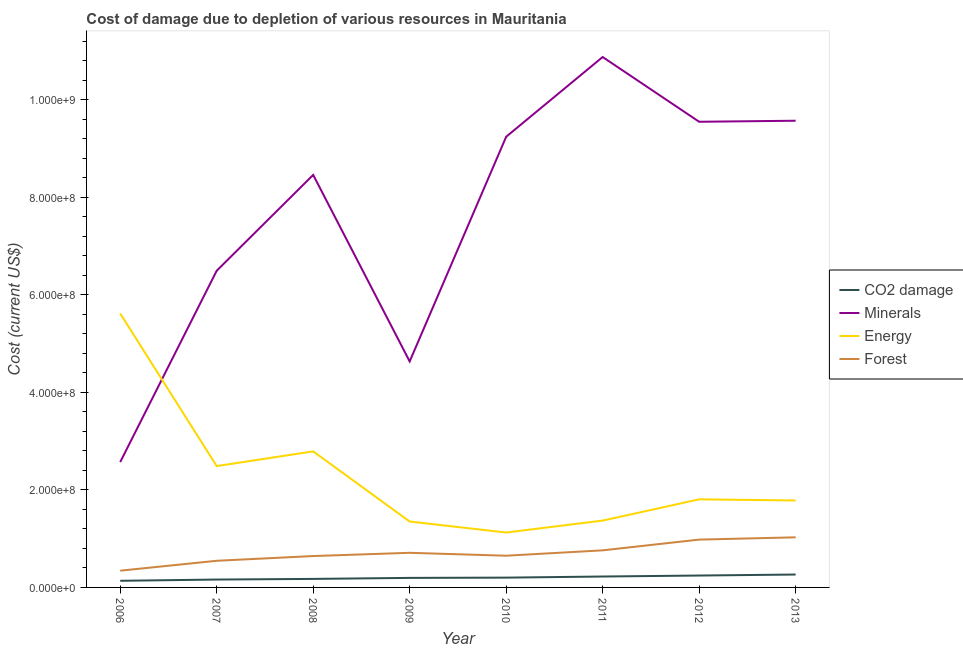Is the number of lines equal to the number of legend labels?
Your answer should be very brief. Yes. What is the cost of damage due to depletion of forests in 2012?
Offer a very short reply. 9.81e+07. Across all years, what is the maximum cost of damage due to depletion of minerals?
Your answer should be very brief. 1.09e+09. Across all years, what is the minimum cost of damage due to depletion of forests?
Offer a terse response. 3.44e+07. In which year was the cost of damage due to depletion of minerals minimum?
Provide a succinct answer. 2006. What is the total cost of damage due to depletion of forests in the graph?
Give a very brief answer. 5.66e+08. What is the difference between the cost of damage due to depletion of forests in 2009 and that in 2012?
Keep it short and to the point. -2.71e+07. What is the difference between the cost of damage due to depletion of minerals in 2011 and the cost of damage due to depletion of coal in 2007?
Provide a succinct answer. 1.07e+09. What is the average cost of damage due to depletion of minerals per year?
Offer a terse response. 7.68e+08. In the year 2011, what is the difference between the cost of damage due to depletion of minerals and cost of damage due to depletion of coal?
Provide a succinct answer. 1.07e+09. In how many years, is the cost of damage due to depletion of forests greater than 240000000 US$?
Provide a short and direct response. 0. What is the ratio of the cost of damage due to depletion of minerals in 2007 to that in 2013?
Your response must be concise. 0.68. What is the difference between the highest and the second highest cost of damage due to depletion of coal?
Offer a very short reply. 2.04e+06. What is the difference between the highest and the lowest cost of damage due to depletion of forests?
Your response must be concise. 6.84e+07. In how many years, is the cost of damage due to depletion of minerals greater than the average cost of damage due to depletion of minerals taken over all years?
Your answer should be compact. 5. Is the cost of damage due to depletion of forests strictly greater than the cost of damage due to depletion of minerals over the years?
Keep it short and to the point. No. Is the cost of damage due to depletion of energy strictly less than the cost of damage due to depletion of coal over the years?
Provide a succinct answer. No. How many lines are there?
Your response must be concise. 4. How many years are there in the graph?
Keep it short and to the point. 8. What is the difference between two consecutive major ticks on the Y-axis?
Offer a very short reply. 2.00e+08. Are the values on the major ticks of Y-axis written in scientific E-notation?
Keep it short and to the point. Yes. How are the legend labels stacked?
Your answer should be compact. Vertical. What is the title of the graph?
Offer a terse response. Cost of damage due to depletion of various resources in Mauritania . What is the label or title of the X-axis?
Provide a short and direct response. Year. What is the label or title of the Y-axis?
Keep it short and to the point. Cost (current US$). What is the Cost (current US$) in CO2 damage in 2006?
Your response must be concise. 1.36e+07. What is the Cost (current US$) in Minerals in 2006?
Offer a terse response. 2.57e+08. What is the Cost (current US$) of Energy in 2006?
Your response must be concise. 5.62e+08. What is the Cost (current US$) in Forest in 2006?
Your response must be concise. 3.44e+07. What is the Cost (current US$) in CO2 damage in 2007?
Make the answer very short. 1.62e+07. What is the Cost (current US$) of Minerals in 2007?
Provide a short and direct response. 6.50e+08. What is the Cost (current US$) of Energy in 2007?
Offer a very short reply. 2.49e+08. What is the Cost (current US$) in Forest in 2007?
Give a very brief answer. 5.47e+07. What is the Cost (current US$) of CO2 damage in 2008?
Your answer should be very brief. 1.75e+07. What is the Cost (current US$) of Minerals in 2008?
Your answer should be compact. 8.46e+08. What is the Cost (current US$) in Energy in 2008?
Provide a short and direct response. 2.79e+08. What is the Cost (current US$) in Forest in 2008?
Your answer should be very brief. 6.44e+07. What is the Cost (current US$) in CO2 damage in 2009?
Offer a very short reply. 1.96e+07. What is the Cost (current US$) of Minerals in 2009?
Provide a succinct answer. 4.64e+08. What is the Cost (current US$) of Energy in 2009?
Your answer should be compact. 1.35e+08. What is the Cost (current US$) in Forest in 2009?
Give a very brief answer. 7.10e+07. What is the Cost (current US$) in CO2 damage in 2010?
Your response must be concise. 2.01e+07. What is the Cost (current US$) in Minerals in 2010?
Your response must be concise. 9.25e+08. What is the Cost (current US$) in Energy in 2010?
Offer a very short reply. 1.13e+08. What is the Cost (current US$) in Forest in 2010?
Make the answer very short. 6.51e+07. What is the Cost (current US$) of CO2 damage in 2011?
Keep it short and to the point. 2.24e+07. What is the Cost (current US$) in Minerals in 2011?
Offer a very short reply. 1.09e+09. What is the Cost (current US$) in Energy in 2011?
Ensure brevity in your answer.  1.37e+08. What is the Cost (current US$) in Forest in 2011?
Your answer should be very brief. 7.61e+07. What is the Cost (current US$) of CO2 damage in 2012?
Your answer should be very brief. 2.44e+07. What is the Cost (current US$) of Minerals in 2012?
Provide a succinct answer. 9.55e+08. What is the Cost (current US$) of Energy in 2012?
Provide a succinct answer. 1.81e+08. What is the Cost (current US$) of Forest in 2012?
Keep it short and to the point. 9.81e+07. What is the Cost (current US$) in CO2 damage in 2013?
Give a very brief answer. 2.65e+07. What is the Cost (current US$) in Minerals in 2013?
Ensure brevity in your answer.  9.57e+08. What is the Cost (current US$) of Energy in 2013?
Offer a very short reply. 1.78e+08. What is the Cost (current US$) in Forest in 2013?
Offer a terse response. 1.03e+08. Across all years, what is the maximum Cost (current US$) in CO2 damage?
Your answer should be very brief. 2.65e+07. Across all years, what is the maximum Cost (current US$) in Minerals?
Provide a short and direct response. 1.09e+09. Across all years, what is the maximum Cost (current US$) of Energy?
Ensure brevity in your answer.  5.62e+08. Across all years, what is the maximum Cost (current US$) of Forest?
Give a very brief answer. 1.03e+08. Across all years, what is the minimum Cost (current US$) in CO2 damage?
Ensure brevity in your answer.  1.36e+07. Across all years, what is the minimum Cost (current US$) in Minerals?
Your answer should be very brief. 2.57e+08. Across all years, what is the minimum Cost (current US$) of Energy?
Make the answer very short. 1.13e+08. Across all years, what is the minimum Cost (current US$) of Forest?
Your response must be concise. 3.44e+07. What is the total Cost (current US$) in CO2 damage in the graph?
Ensure brevity in your answer.  1.60e+08. What is the total Cost (current US$) in Minerals in the graph?
Offer a very short reply. 6.14e+09. What is the total Cost (current US$) of Energy in the graph?
Provide a succinct answer. 1.83e+09. What is the total Cost (current US$) in Forest in the graph?
Keep it short and to the point. 5.66e+08. What is the difference between the Cost (current US$) of CO2 damage in 2006 and that in 2007?
Your response must be concise. -2.56e+06. What is the difference between the Cost (current US$) in Minerals in 2006 and that in 2007?
Offer a terse response. -3.93e+08. What is the difference between the Cost (current US$) of Energy in 2006 and that in 2007?
Provide a short and direct response. 3.13e+08. What is the difference between the Cost (current US$) in Forest in 2006 and that in 2007?
Your answer should be compact. -2.03e+07. What is the difference between the Cost (current US$) of CO2 damage in 2006 and that in 2008?
Your answer should be compact. -3.88e+06. What is the difference between the Cost (current US$) in Minerals in 2006 and that in 2008?
Offer a terse response. -5.89e+08. What is the difference between the Cost (current US$) in Energy in 2006 and that in 2008?
Your answer should be very brief. 2.83e+08. What is the difference between the Cost (current US$) of Forest in 2006 and that in 2008?
Make the answer very short. -3.00e+07. What is the difference between the Cost (current US$) in CO2 damage in 2006 and that in 2009?
Provide a succinct answer. -5.98e+06. What is the difference between the Cost (current US$) in Minerals in 2006 and that in 2009?
Provide a succinct answer. -2.07e+08. What is the difference between the Cost (current US$) in Energy in 2006 and that in 2009?
Provide a short and direct response. 4.27e+08. What is the difference between the Cost (current US$) in Forest in 2006 and that in 2009?
Offer a terse response. -3.67e+07. What is the difference between the Cost (current US$) in CO2 damage in 2006 and that in 2010?
Keep it short and to the point. -6.50e+06. What is the difference between the Cost (current US$) of Minerals in 2006 and that in 2010?
Make the answer very short. -6.67e+08. What is the difference between the Cost (current US$) of Energy in 2006 and that in 2010?
Give a very brief answer. 4.49e+08. What is the difference between the Cost (current US$) of Forest in 2006 and that in 2010?
Make the answer very short. -3.07e+07. What is the difference between the Cost (current US$) of CO2 damage in 2006 and that in 2011?
Offer a terse response. -8.80e+06. What is the difference between the Cost (current US$) of Minerals in 2006 and that in 2011?
Provide a short and direct response. -8.31e+08. What is the difference between the Cost (current US$) in Energy in 2006 and that in 2011?
Ensure brevity in your answer.  4.25e+08. What is the difference between the Cost (current US$) of Forest in 2006 and that in 2011?
Provide a short and direct response. -4.17e+07. What is the difference between the Cost (current US$) of CO2 damage in 2006 and that in 2012?
Provide a succinct answer. -1.08e+07. What is the difference between the Cost (current US$) of Minerals in 2006 and that in 2012?
Offer a terse response. -6.98e+08. What is the difference between the Cost (current US$) of Energy in 2006 and that in 2012?
Provide a succinct answer. 3.81e+08. What is the difference between the Cost (current US$) in Forest in 2006 and that in 2012?
Make the answer very short. -6.38e+07. What is the difference between the Cost (current US$) in CO2 damage in 2006 and that in 2013?
Keep it short and to the point. -1.29e+07. What is the difference between the Cost (current US$) in Minerals in 2006 and that in 2013?
Your response must be concise. -7.00e+08. What is the difference between the Cost (current US$) in Energy in 2006 and that in 2013?
Offer a very short reply. 3.84e+08. What is the difference between the Cost (current US$) of Forest in 2006 and that in 2013?
Your answer should be very brief. -6.84e+07. What is the difference between the Cost (current US$) of CO2 damage in 2007 and that in 2008?
Provide a short and direct response. -1.32e+06. What is the difference between the Cost (current US$) in Minerals in 2007 and that in 2008?
Provide a short and direct response. -1.97e+08. What is the difference between the Cost (current US$) of Energy in 2007 and that in 2008?
Give a very brief answer. -3.02e+07. What is the difference between the Cost (current US$) of Forest in 2007 and that in 2008?
Give a very brief answer. -9.72e+06. What is the difference between the Cost (current US$) of CO2 damage in 2007 and that in 2009?
Offer a very short reply. -3.42e+06. What is the difference between the Cost (current US$) in Minerals in 2007 and that in 2009?
Give a very brief answer. 1.86e+08. What is the difference between the Cost (current US$) in Energy in 2007 and that in 2009?
Offer a terse response. 1.14e+08. What is the difference between the Cost (current US$) in Forest in 2007 and that in 2009?
Make the answer very short. -1.64e+07. What is the difference between the Cost (current US$) in CO2 damage in 2007 and that in 2010?
Offer a very short reply. -3.94e+06. What is the difference between the Cost (current US$) of Minerals in 2007 and that in 2010?
Offer a very short reply. -2.75e+08. What is the difference between the Cost (current US$) in Energy in 2007 and that in 2010?
Keep it short and to the point. 1.36e+08. What is the difference between the Cost (current US$) in Forest in 2007 and that in 2010?
Your answer should be very brief. -1.04e+07. What is the difference between the Cost (current US$) of CO2 damage in 2007 and that in 2011?
Make the answer very short. -6.24e+06. What is the difference between the Cost (current US$) in Minerals in 2007 and that in 2011?
Offer a terse response. -4.38e+08. What is the difference between the Cost (current US$) of Energy in 2007 and that in 2011?
Provide a short and direct response. 1.12e+08. What is the difference between the Cost (current US$) in Forest in 2007 and that in 2011?
Your response must be concise. -2.14e+07. What is the difference between the Cost (current US$) in CO2 damage in 2007 and that in 2012?
Make the answer very short. -8.25e+06. What is the difference between the Cost (current US$) of Minerals in 2007 and that in 2012?
Make the answer very short. -3.06e+08. What is the difference between the Cost (current US$) in Energy in 2007 and that in 2012?
Offer a very short reply. 6.82e+07. What is the difference between the Cost (current US$) in Forest in 2007 and that in 2012?
Offer a terse response. -4.34e+07. What is the difference between the Cost (current US$) in CO2 damage in 2007 and that in 2013?
Offer a very short reply. -1.03e+07. What is the difference between the Cost (current US$) of Minerals in 2007 and that in 2013?
Give a very brief answer. -3.08e+08. What is the difference between the Cost (current US$) in Energy in 2007 and that in 2013?
Your response must be concise. 7.06e+07. What is the difference between the Cost (current US$) in Forest in 2007 and that in 2013?
Your response must be concise. -4.81e+07. What is the difference between the Cost (current US$) of CO2 damage in 2008 and that in 2009?
Provide a succinct answer. -2.10e+06. What is the difference between the Cost (current US$) of Minerals in 2008 and that in 2009?
Provide a succinct answer. 3.83e+08. What is the difference between the Cost (current US$) in Energy in 2008 and that in 2009?
Keep it short and to the point. 1.44e+08. What is the difference between the Cost (current US$) of Forest in 2008 and that in 2009?
Provide a short and direct response. -6.65e+06. What is the difference between the Cost (current US$) in CO2 damage in 2008 and that in 2010?
Ensure brevity in your answer.  -2.62e+06. What is the difference between the Cost (current US$) of Minerals in 2008 and that in 2010?
Provide a short and direct response. -7.82e+07. What is the difference between the Cost (current US$) of Energy in 2008 and that in 2010?
Offer a very short reply. 1.66e+08. What is the difference between the Cost (current US$) of Forest in 2008 and that in 2010?
Keep it short and to the point. -6.86e+05. What is the difference between the Cost (current US$) of CO2 damage in 2008 and that in 2011?
Provide a short and direct response. -4.92e+06. What is the difference between the Cost (current US$) in Minerals in 2008 and that in 2011?
Offer a terse response. -2.42e+08. What is the difference between the Cost (current US$) of Energy in 2008 and that in 2011?
Make the answer very short. 1.42e+08. What is the difference between the Cost (current US$) of Forest in 2008 and that in 2011?
Provide a short and direct response. -1.17e+07. What is the difference between the Cost (current US$) of CO2 damage in 2008 and that in 2012?
Your response must be concise. -6.94e+06. What is the difference between the Cost (current US$) of Minerals in 2008 and that in 2012?
Your response must be concise. -1.09e+08. What is the difference between the Cost (current US$) of Energy in 2008 and that in 2012?
Your answer should be compact. 9.84e+07. What is the difference between the Cost (current US$) of Forest in 2008 and that in 2012?
Your answer should be very brief. -3.37e+07. What is the difference between the Cost (current US$) of CO2 damage in 2008 and that in 2013?
Your answer should be compact. -8.98e+06. What is the difference between the Cost (current US$) of Minerals in 2008 and that in 2013?
Give a very brief answer. -1.11e+08. What is the difference between the Cost (current US$) in Energy in 2008 and that in 2013?
Your answer should be compact. 1.01e+08. What is the difference between the Cost (current US$) in Forest in 2008 and that in 2013?
Your answer should be very brief. -3.84e+07. What is the difference between the Cost (current US$) of CO2 damage in 2009 and that in 2010?
Ensure brevity in your answer.  -5.16e+05. What is the difference between the Cost (current US$) in Minerals in 2009 and that in 2010?
Provide a succinct answer. -4.61e+08. What is the difference between the Cost (current US$) of Energy in 2009 and that in 2010?
Give a very brief answer. 2.26e+07. What is the difference between the Cost (current US$) of Forest in 2009 and that in 2010?
Offer a very short reply. 5.96e+06. What is the difference between the Cost (current US$) of CO2 damage in 2009 and that in 2011?
Your response must be concise. -2.82e+06. What is the difference between the Cost (current US$) in Minerals in 2009 and that in 2011?
Your answer should be compact. -6.24e+08. What is the difference between the Cost (current US$) of Energy in 2009 and that in 2011?
Offer a very short reply. -1.92e+06. What is the difference between the Cost (current US$) of Forest in 2009 and that in 2011?
Offer a very short reply. -5.06e+06. What is the difference between the Cost (current US$) in CO2 damage in 2009 and that in 2012?
Your answer should be very brief. -4.83e+06. What is the difference between the Cost (current US$) of Minerals in 2009 and that in 2012?
Give a very brief answer. -4.92e+08. What is the difference between the Cost (current US$) in Energy in 2009 and that in 2012?
Your answer should be very brief. -4.55e+07. What is the difference between the Cost (current US$) in Forest in 2009 and that in 2012?
Offer a very short reply. -2.71e+07. What is the difference between the Cost (current US$) in CO2 damage in 2009 and that in 2013?
Your answer should be very brief. -6.88e+06. What is the difference between the Cost (current US$) in Minerals in 2009 and that in 2013?
Provide a short and direct response. -4.94e+08. What is the difference between the Cost (current US$) in Energy in 2009 and that in 2013?
Provide a short and direct response. -4.32e+07. What is the difference between the Cost (current US$) in Forest in 2009 and that in 2013?
Offer a terse response. -3.18e+07. What is the difference between the Cost (current US$) of CO2 damage in 2010 and that in 2011?
Provide a short and direct response. -2.30e+06. What is the difference between the Cost (current US$) of Minerals in 2010 and that in 2011?
Provide a short and direct response. -1.64e+08. What is the difference between the Cost (current US$) in Energy in 2010 and that in 2011?
Provide a short and direct response. -2.45e+07. What is the difference between the Cost (current US$) in Forest in 2010 and that in 2011?
Ensure brevity in your answer.  -1.10e+07. What is the difference between the Cost (current US$) of CO2 damage in 2010 and that in 2012?
Make the answer very short. -4.32e+06. What is the difference between the Cost (current US$) of Minerals in 2010 and that in 2012?
Make the answer very short. -3.08e+07. What is the difference between the Cost (current US$) of Energy in 2010 and that in 2012?
Your answer should be compact. -6.81e+07. What is the difference between the Cost (current US$) of Forest in 2010 and that in 2012?
Offer a very short reply. -3.30e+07. What is the difference between the Cost (current US$) in CO2 damage in 2010 and that in 2013?
Ensure brevity in your answer.  -6.36e+06. What is the difference between the Cost (current US$) in Minerals in 2010 and that in 2013?
Keep it short and to the point. -3.29e+07. What is the difference between the Cost (current US$) of Energy in 2010 and that in 2013?
Offer a very short reply. -6.57e+07. What is the difference between the Cost (current US$) of Forest in 2010 and that in 2013?
Your answer should be very brief. -3.77e+07. What is the difference between the Cost (current US$) in CO2 damage in 2011 and that in 2012?
Your answer should be compact. -2.02e+06. What is the difference between the Cost (current US$) in Minerals in 2011 and that in 2012?
Make the answer very short. 1.33e+08. What is the difference between the Cost (current US$) of Energy in 2011 and that in 2012?
Provide a short and direct response. -4.36e+07. What is the difference between the Cost (current US$) of Forest in 2011 and that in 2012?
Offer a very short reply. -2.20e+07. What is the difference between the Cost (current US$) of CO2 damage in 2011 and that in 2013?
Give a very brief answer. -4.06e+06. What is the difference between the Cost (current US$) in Minerals in 2011 and that in 2013?
Your answer should be compact. 1.31e+08. What is the difference between the Cost (current US$) in Energy in 2011 and that in 2013?
Your response must be concise. -4.12e+07. What is the difference between the Cost (current US$) in Forest in 2011 and that in 2013?
Ensure brevity in your answer.  -2.67e+07. What is the difference between the Cost (current US$) of CO2 damage in 2012 and that in 2013?
Offer a terse response. -2.04e+06. What is the difference between the Cost (current US$) in Minerals in 2012 and that in 2013?
Your answer should be very brief. -2.13e+06. What is the difference between the Cost (current US$) of Energy in 2012 and that in 2013?
Provide a succinct answer. 2.34e+06. What is the difference between the Cost (current US$) of Forest in 2012 and that in 2013?
Provide a short and direct response. -4.69e+06. What is the difference between the Cost (current US$) in CO2 damage in 2006 and the Cost (current US$) in Minerals in 2007?
Provide a short and direct response. -6.36e+08. What is the difference between the Cost (current US$) of CO2 damage in 2006 and the Cost (current US$) of Energy in 2007?
Provide a succinct answer. -2.35e+08. What is the difference between the Cost (current US$) in CO2 damage in 2006 and the Cost (current US$) in Forest in 2007?
Offer a terse response. -4.11e+07. What is the difference between the Cost (current US$) of Minerals in 2006 and the Cost (current US$) of Energy in 2007?
Provide a succinct answer. 8.22e+06. What is the difference between the Cost (current US$) of Minerals in 2006 and the Cost (current US$) of Forest in 2007?
Your response must be concise. 2.02e+08. What is the difference between the Cost (current US$) in Energy in 2006 and the Cost (current US$) in Forest in 2007?
Your response must be concise. 5.07e+08. What is the difference between the Cost (current US$) in CO2 damage in 2006 and the Cost (current US$) in Minerals in 2008?
Make the answer very short. -8.33e+08. What is the difference between the Cost (current US$) in CO2 damage in 2006 and the Cost (current US$) in Energy in 2008?
Provide a succinct answer. -2.66e+08. What is the difference between the Cost (current US$) in CO2 damage in 2006 and the Cost (current US$) in Forest in 2008?
Keep it short and to the point. -5.08e+07. What is the difference between the Cost (current US$) of Minerals in 2006 and the Cost (current US$) of Energy in 2008?
Ensure brevity in your answer.  -2.19e+07. What is the difference between the Cost (current US$) in Minerals in 2006 and the Cost (current US$) in Forest in 2008?
Your response must be concise. 1.93e+08. What is the difference between the Cost (current US$) of Energy in 2006 and the Cost (current US$) of Forest in 2008?
Your answer should be very brief. 4.98e+08. What is the difference between the Cost (current US$) of CO2 damage in 2006 and the Cost (current US$) of Minerals in 2009?
Your answer should be very brief. -4.50e+08. What is the difference between the Cost (current US$) in CO2 damage in 2006 and the Cost (current US$) in Energy in 2009?
Your answer should be very brief. -1.22e+08. What is the difference between the Cost (current US$) of CO2 damage in 2006 and the Cost (current US$) of Forest in 2009?
Offer a very short reply. -5.74e+07. What is the difference between the Cost (current US$) in Minerals in 2006 and the Cost (current US$) in Energy in 2009?
Your answer should be very brief. 1.22e+08. What is the difference between the Cost (current US$) of Minerals in 2006 and the Cost (current US$) of Forest in 2009?
Make the answer very short. 1.86e+08. What is the difference between the Cost (current US$) in Energy in 2006 and the Cost (current US$) in Forest in 2009?
Provide a succinct answer. 4.91e+08. What is the difference between the Cost (current US$) in CO2 damage in 2006 and the Cost (current US$) in Minerals in 2010?
Make the answer very short. -9.11e+08. What is the difference between the Cost (current US$) of CO2 damage in 2006 and the Cost (current US$) of Energy in 2010?
Give a very brief answer. -9.90e+07. What is the difference between the Cost (current US$) of CO2 damage in 2006 and the Cost (current US$) of Forest in 2010?
Offer a terse response. -5.15e+07. What is the difference between the Cost (current US$) of Minerals in 2006 and the Cost (current US$) of Energy in 2010?
Keep it short and to the point. 1.45e+08. What is the difference between the Cost (current US$) of Minerals in 2006 and the Cost (current US$) of Forest in 2010?
Make the answer very short. 1.92e+08. What is the difference between the Cost (current US$) of Energy in 2006 and the Cost (current US$) of Forest in 2010?
Ensure brevity in your answer.  4.97e+08. What is the difference between the Cost (current US$) in CO2 damage in 2006 and the Cost (current US$) in Minerals in 2011?
Make the answer very short. -1.07e+09. What is the difference between the Cost (current US$) of CO2 damage in 2006 and the Cost (current US$) of Energy in 2011?
Offer a terse response. -1.24e+08. What is the difference between the Cost (current US$) in CO2 damage in 2006 and the Cost (current US$) in Forest in 2011?
Ensure brevity in your answer.  -6.25e+07. What is the difference between the Cost (current US$) of Minerals in 2006 and the Cost (current US$) of Energy in 2011?
Your response must be concise. 1.20e+08. What is the difference between the Cost (current US$) in Minerals in 2006 and the Cost (current US$) in Forest in 2011?
Your answer should be very brief. 1.81e+08. What is the difference between the Cost (current US$) in Energy in 2006 and the Cost (current US$) in Forest in 2011?
Ensure brevity in your answer.  4.86e+08. What is the difference between the Cost (current US$) in CO2 damage in 2006 and the Cost (current US$) in Minerals in 2012?
Give a very brief answer. -9.42e+08. What is the difference between the Cost (current US$) in CO2 damage in 2006 and the Cost (current US$) in Energy in 2012?
Provide a succinct answer. -1.67e+08. What is the difference between the Cost (current US$) of CO2 damage in 2006 and the Cost (current US$) of Forest in 2012?
Make the answer very short. -8.45e+07. What is the difference between the Cost (current US$) of Minerals in 2006 and the Cost (current US$) of Energy in 2012?
Ensure brevity in your answer.  7.65e+07. What is the difference between the Cost (current US$) of Minerals in 2006 and the Cost (current US$) of Forest in 2012?
Your response must be concise. 1.59e+08. What is the difference between the Cost (current US$) of Energy in 2006 and the Cost (current US$) of Forest in 2012?
Offer a terse response. 4.64e+08. What is the difference between the Cost (current US$) of CO2 damage in 2006 and the Cost (current US$) of Minerals in 2013?
Offer a terse response. -9.44e+08. What is the difference between the Cost (current US$) of CO2 damage in 2006 and the Cost (current US$) of Energy in 2013?
Offer a very short reply. -1.65e+08. What is the difference between the Cost (current US$) in CO2 damage in 2006 and the Cost (current US$) in Forest in 2013?
Make the answer very short. -8.92e+07. What is the difference between the Cost (current US$) of Minerals in 2006 and the Cost (current US$) of Energy in 2013?
Give a very brief answer. 7.88e+07. What is the difference between the Cost (current US$) in Minerals in 2006 and the Cost (current US$) in Forest in 2013?
Provide a short and direct response. 1.54e+08. What is the difference between the Cost (current US$) of Energy in 2006 and the Cost (current US$) of Forest in 2013?
Offer a terse response. 4.59e+08. What is the difference between the Cost (current US$) of CO2 damage in 2007 and the Cost (current US$) of Minerals in 2008?
Your answer should be very brief. -8.30e+08. What is the difference between the Cost (current US$) in CO2 damage in 2007 and the Cost (current US$) in Energy in 2008?
Ensure brevity in your answer.  -2.63e+08. What is the difference between the Cost (current US$) in CO2 damage in 2007 and the Cost (current US$) in Forest in 2008?
Provide a short and direct response. -4.82e+07. What is the difference between the Cost (current US$) in Minerals in 2007 and the Cost (current US$) in Energy in 2008?
Ensure brevity in your answer.  3.71e+08. What is the difference between the Cost (current US$) in Minerals in 2007 and the Cost (current US$) in Forest in 2008?
Make the answer very short. 5.85e+08. What is the difference between the Cost (current US$) in Energy in 2007 and the Cost (current US$) in Forest in 2008?
Your response must be concise. 1.85e+08. What is the difference between the Cost (current US$) of CO2 damage in 2007 and the Cost (current US$) of Minerals in 2009?
Make the answer very short. -4.48e+08. What is the difference between the Cost (current US$) of CO2 damage in 2007 and the Cost (current US$) of Energy in 2009?
Give a very brief answer. -1.19e+08. What is the difference between the Cost (current US$) of CO2 damage in 2007 and the Cost (current US$) of Forest in 2009?
Your answer should be very brief. -5.49e+07. What is the difference between the Cost (current US$) of Minerals in 2007 and the Cost (current US$) of Energy in 2009?
Your answer should be compact. 5.14e+08. What is the difference between the Cost (current US$) of Minerals in 2007 and the Cost (current US$) of Forest in 2009?
Keep it short and to the point. 5.79e+08. What is the difference between the Cost (current US$) of Energy in 2007 and the Cost (current US$) of Forest in 2009?
Provide a succinct answer. 1.78e+08. What is the difference between the Cost (current US$) in CO2 damage in 2007 and the Cost (current US$) in Minerals in 2010?
Your response must be concise. -9.08e+08. What is the difference between the Cost (current US$) of CO2 damage in 2007 and the Cost (current US$) of Energy in 2010?
Make the answer very short. -9.65e+07. What is the difference between the Cost (current US$) in CO2 damage in 2007 and the Cost (current US$) in Forest in 2010?
Offer a very short reply. -4.89e+07. What is the difference between the Cost (current US$) of Minerals in 2007 and the Cost (current US$) of Energy in 2010?
Keep it short and to the point. 5.37e+08. What is the difference between the Cost (current US$) of Minerals in 2007 and the Cost (current US$) of Forest in 2010?
Keep it short and to the point. 5.85e+08. What is the difference between the Cost (current US$) of Energy in 2007 and the Cost (current US$) of Forest in 2010?
Provide a succinct answer. 1.84e+08. What is the difference between the Cost (current US$) in CO2 damage in 2007 and the Cost (current US$) in Minerals in 2011?
Offer a very short reply. -1.07e+09. What is the difference between the Cost (current US$) in CO2 damage in 2007 and the Cost (current US$) in Energy in 2011?
Provide a succinct answer. -1.21e+08. What is the difference between the Cost (current US$) in CO2 damage in 2007 and the Cost (current US$) in Forest in 2011?
Provide a short and direct response. -5.99e+07. What is the difference between the Cost (current US$) of Minerals in 2007 and the Cost (current US$) of Energy in 2011?
Offer a terse response. 5.13e+08. What is the difference between the Cost (current US$) of Minerals in 2007 and the Cost (current US$) of Forest in 2011?
Keep it short and to the point. 5.74e+08. What is the difference between the Cost (current US$) in Energy in 2007 and the Cost (current US$) in Forest in 2011?
Your answer should be compact. 1.73e+08. What is the difference between the Cost (current US$) of CO2 damage in 2007 and the Cost (current US$) of Minerals in 2012?
Provide a short and direct response. -9.39e+08. What is the difference between the Cost (current US$) of CO2 damage in 2007 and the Cost (current US$) of Energy in 2012?
Give a very brief answer. -1.65e+08. What is the difference between the Cost (current US$) of CO2 damage in 2007 and the Cost (current US$) of Forest in 2012?
Keep it short and to the point. -8.19e+07. What is the difference between the Cost (current US$) of Minerals in 2007 and the Cost (current US$) of Energy in 2012?
Provide a succinct answer. 4.69e+08. What is the difference between the Cost (current US$) in Minerals in 2007 and the Cost (current US$) in Forest in 2012?
Your answer should be compact. 5.52e+08. What is the difference between the Cost (current US$) of Energy in 2007 and the Cost (current US$) of Forest in 2012?
Offer a very short reply. 1.51e+08. What is the difference between the Cost (current US$) in CO2 damage in 2007 and the Cost (current US$) in Minerals in 2013?
Keep it short and to the point. -9.41e+08. What is the difference between the Cost (current US$) of CO2 damage in 2007 and the Cost (current US$) of Energy in 2013?
Provide a succinct answer. -1.62e+08. What is the difference between the Cost (current US$) of CO2 damage in 2007 and the Cost (current US$) of Forest in 2013?
Offer a terse response. -8.66e+07. What is the difference between the Cost (current US$) of Minerals in 2007 and the Cost (current US$) of Energy in 2013?
Keep it short and to the point. 4.71e+08. What is the difference between the Cost (current US$) in Minerals in 2007 and the Cost (current US$) in Forest in 2013?
Your answer should be compact. 5.47e+08. What is the difference between the Cost (current US$) in Energy in 2007 and the Cost (current US$) in Forest in 2013?
Your response must be concise. 1.46e+08. What is the difference between the Cost (current US$) of CO2 damage in 2008 and the Cost (current US$) of Minerals in 2009?
Make the answer very short. -4.46e+08. What is the difference between the Cost (current US$) in CO2 damage in 2008 and the Cost (current US$) in Energy in 2009?
Your response must be concise. -1.18e+08. What is the difference between the Cost (current US$) of CO2 damage in 2008 and the Cost (current US$) of Forest in 2009?
Keep it short and to the point. -5.36e+07. What is the difference between the Cost (current US$) in Minerals in 2008 and the Cost (current US$) in Energy in 2009?
Offer a terse response. 7.11e+08. What is the difference between the Cost (current US$) in Minerals in 2008 and the Cost (current US$) in Forest in 2009?
Make the answer very short. 7.75e+08. What is the difference between the Cost (current US$) of Energy in 2008 and the Cost (current US$) of Forest in 2009?
Offer a terse response. 2.08e+08. What is the difference between the Cost (current US$) in CO2 damage in 2008 and the Cost (current US$) in Minerals in 2010?
Make the answer very short. -9.07e+08. What is the difference between the Cost (current US$) of CO2 damage in 2008 and the Cost (current US$) of Energy in 2010?
Offer a very short reply. -9.52e+07. What is the difference between the Cost (current US$) in CO2 damage in 2008 and the Cost (current US$) in Forest in 2010?
Provide a succinct answer. -4.76e+07. What is the difference between the Cost (current US$) in Minerals in 2008 and the Cost (current US$) in Energy in 2010?
Your answer should be very brief. 7.34e+08. What is the difference between the Cost (current US$) in Minerals in 2008 and the Cost (current US$) in Forest in 2010?
Ensure brevity in your answer.  7.81e+08. What is the difference between the Cost (current US$) of Energy in 2008 and the Cost (current US$) of Forest in 2010?
Keep it short and to the point. 2.14e+08. What is the difference between the Cost (current US$) of CO2 damage in 2008 and the Cost (current US$) of Minerals in 2011?
Keep it short and to the point. -1.07e+09. What is the difference between the Cost (current US$) of CO2 damage in 2008 and the Cost (current US$) of Energy in 2011?
Offer a terse response. -1.20e+08. What is the difference between the Cost (current US$) of CO2 damage in 2008 and the Cost (current US$) of Forest in 2011?
Give a very brief answer. -5.86e+07. What is the difference between the Cost (current US$) of Minerals in 2008 and the Cost (current US$) of Energy in 2011?
Offer a terse response. 7.09e+08. What is the difference between the Cost (current US$) of Minerals in 2008 and the Cost (current US$) of Forest in 2011?
Give a very brief answer. 7.70e+08. What is the difference between the Cost (current US$) in Energy in 2008 and the Cost (current US$) in Forest in 2011?
Your response must be concise. 2.03e+08. What is the difference between the Cost (current US$) in CO2 damage in 2008 and the Cost (current US$) in Minerals in 2012?
Your answer should be very brief. -9.38e+08. What is the difference between the Cost (current US$) of CO2 damage in 2008 and the Cost (current US$) of Energy in 2012?
Ensure brevity in your answer.  -1.63e+08. What is the difference between the Cost (current US$) of CO2 damage in 2008 and the Cost (current US$) of Forest in 2012?
Offer a terse response. -8.06e+07. What is the difference between the Cost (current US$) in Minerals in 2008 and the Cost (current US$) in Energy in 2012?
Provide a succinct answer. 6.66e+08. What is the difference between the Cost (current US$) in Minerals in 2008 and the Cost (current US$) in Forest in 2012?
Ensure brevity in your answer.  7.48e+08. What is the difference between the Cost (current US$) of Energy in 2008 and the Cost (current US$) of Forest in 2012?
Your answer should be very brief. 1.81e+08. What is the difference between the Cost (current US$) in CO2 damage in 2008 and the Cost (current US$) in Minerals in 2013?
Offer a terse response. -9.40e+08. What is the difference between the Cost (current US$) in CO2 damage in 2008 and the Cost (current US$) in Energy in 2013?
Offer a terse response. -1.61e+08. What is the difference between the Cost (current US$) in CO2 damage in 2008 and the Cost (current US$) in Forest in 2013?
Your answer should be compact. -8.53e+07. What is the difference between the Cost (current US$) in Minerals in 2008 and the Cost (current US$) in Energy in 2013?
Your answer should be compact. 6.68e+08. What is the difference between the Cost (current US$) in Minerals in 2008 and the Cost (current US$) in Forest in 2013?
Your answer should be compact. 7.44e+08. What is the difference between the Cost (current US$) of Energy in 2008 and the Cost (current US$) of Forest in 2013?
Your response must be concise. 1.76e+08. What is the difference between the Cost (current US$) in CO2 damage in 2009 and the Cost (current US$) in Minerals in 2010?
Keep it short and to the point. -9.05e+08. What is the difference between the Cost (current US$) of CO2 damage in 2009 and the Cost (current US$) of Energy in 2010?
Give a very brief answer. -9.31e+07. What is the difference between the Cost (current US$) in CO2 damage in 2009 and the Cost (current US$) in Forest in 2010?
Provide a short and direct response. -4.55e+07. What is the difference between the Cost (current US$) of Minerals in 2009 and the Cost (current US$) of Energy in 2010?
Ensure brevity in your answer.  3.51e+08. What is the difference between the Cost (current US$) in Minerals in 2009 and the Cost (current US$) in Forest in 2010?
Your answer should be very brief. 3.99e+08. What is the difference between the Cost (current US$) in Energy in 2009 and the Cost (current US$) in Forest in 2010?
Make the answer very short. 7.01e+07. What is the difference between the Cost (current US$) of CO2 damage in 2009 and the Cost (current US$) of Minerals in 2011?
Provide a succinct answer. -1.07e+09. What is the difference between the Cost (current US$) of CO2 damage in 2009 and the Cost (current US$) of Energy in 2011?
Your response must be concise. -1.18e+08. What is the difference between the Cost (current US$) in CO2 damage in 2009 and the Cost (current US$) in Forest in 2011?
Your response must be concise. -5.65e+07. What is the difference between the Cost (current US$) of Minerals in 2009 and the Cost (current US$) of Energy in 2011?
Provide a succinct answer. 3.27e+08. What is the difference between the Cost (current US$) in Minerals in 2009 and the Cost (current US$) in Forest in 2011?
Provide a short and direct response. 3.88e+08. What is the difference between the Cost (current US$) in Energy in 2009 and the Cost (current US$) in Forest in 2011?
Your answer should be very brief. 5.91e+07. What is the difference between the Cost (current US$) of CO2 damage in 2009 and the Cost (current US$) of Minerals in 2012?
Your response must be concise. -9.36e+08. What is the difference between the Cost (current US$) of CO2 damage in 2009 and the Cost (current US$) of Energy in 2012?
Your response must be concise. -1.61e+08. What is the difference between the Cost (current US$) of CO2 damage in 2009 and the Cost (current US$) of Forest in 2012?
Provide a short and direct response. -7.85e+07. What is the difference between the Cost (current US$) of Minerals in 2009 and the Cost (current US$) of Energy in 2012?
Provide a short and direct response. 2.83e+08. What is the difference between the Cost (current US$) in Minerals in 2009 and the Cost (current US$) in Forest in 2012?
Provide a short and direct response. 3.66e+08. What is the difference between the Cost (current US$) in Energy in 2009 and the Cost (current US$) in Forest in 2012?
Provide a succinct answer. 3.71e+07. What is the difference between the Cost (current US$) of CO2 damage in 2009 and the Cost (current US$) of Minerals in 2013?
Keep it short and to the point. -9.38e+08. What is the difference between the Cost (current US$) of CO2 damage in 2009 and the Cost (current US$) of Energy in 2013?
Give a very brief answer. -1.59e+08. What is the difference between the Cost (current US$) of CO2 damage in 2009 and the Cost (current US$) of Forest in 2013?
Offer a very short reply. -8.32e+07. What is the difference between the Cost (current US$) of Minerals in 2009 and the Cost (current US$) of Energy in 2013?
Your answer should be very brief. 2.85e+08. What is the difference between the Cost (current US$) of Minerals in 2009 and the Cost (current US$) of Forest in 2013?
Your answer should be compact. 3.61e+08. What is the difference between the Cost (current US$) of Energy in 2009 and the Cost (current US$) of Forest in 2013?
Offer a terse response. 3.24e+07. What is the difference between the Cost (current US$) of CO2 damage in 2010 and the Cost (current US$) of Minerals in 2011?
Ensure brevity in your answer.  -1.07e+09. What is the difference between the Cost (current US$) of CO2 damage in 2010 and the Cost (current US$) of Energy in 2011?
Provide a short and direct response. -1.17e+08. What is the difference between the Cost (current US$) of CO2 damage in 2010 and the Cost (current US$) of Forest in 2011?
Make the answer very short. -5.60e+07. What is the difference between the Cost (current US$) in Minerals in 2010 and the Cost (current US$) in Energy in 2011?
Your answer should be compact. 7.87e+08. What is the difference between the Cost (current US$) in Minerals in 2010 and the Cost (current US$) in Forest in 2011?
Provide a succinct answer. 8.48e+08. What is the difference between the Cost (current US$) of Energy in 2010 and the Cost (current US$) of Forest in 2011?
Your response must be concise. 3.65e+07. What is the difference between the Cost (current US$) in CO2 damage in 2010 and the Cost (current US$) in Minerals in 2012?
Ensure brevity in your answer.  -9.35e+08. What is the difference between the Cost (current US$) of CO2 damage in 2010 and the Cost (current US$) of Energy in 2012?
Provide a short and direct response. -1.61e+08. What is the difference between the Cost (current US$) in CO2 damage in 2010 and the Cost (current US$) in Forest in 2012?
Your answer should be compact. -7.80e+07. What is the difference between the Cost (current US$) of Minerals in 2010 and the Cost (current US$) of Energy in 2012?
Keep it short and to the point. 7.44e+08. What is the difference between the Cost (current US$) of Minerals in 2010 and the Cost (current US$) of Forest in 2012?
Your answer should be very brief. 8.26e+08. What is the difference between the Cost (current US$) in Energy in 2010 and the Cost (current US$) in Forest in 2012?
Provide a succinct answer. 1.45e+07. What is the difference between the Cost (current US$) in CO2 damage in 2010 and the Cost (current US$) in Minerals in 2013?
Keep it short and to the point. -9.37e+08. What is the difference between the Cost (current US$) in CO2 damage in 2010 and the Cost (current US$) in Energy in 2013?
Provide a succinct answer. -1.58e+08. What is the difference between the Cost (current US$) of CO2 damage in 2010 and the Cost (current US$) of Forest in 2013?
Provide a succinct answer. -8.27e+07. What is the difference between the Cost (current US$) in Minerals in 2010 and the Cost (current US$) in Energy in 2013?
Make the answer very short. 7.46e+08. What is the difference between the Cost (current US$) in Minerals in 2010 and the Cost (current US$) in Forest in 2013?
Offer a very short reply. 8.22e+08. What is the difference between the Cost (current US$) of Energy in 2010 and the Cost (current US$) of Forest in 2013?
Offer a very short reply. 9.83e+06. What is the difference between the Cost (current US$) in CO2 damage in 2011 and the Cost (current US$) in Minerals in 2012?
Offer a very short reply. -9.33e+08. What is the difference between the Cost (current US$) of CO2 damage in 2011 and the Cost (current US$) of Energy in 2012?
Offer a very short reply. -1.58e+08. What is the difference between the Cost (current US$) of CO2 damage in 2011 and the Cost (current US$) of Forest in 2012?
Make the answer very short. -7.57e+07. What is the difference between the Cost (current US$) in Minerals in 2011 and the Cost (current US$) in Energy in 2012?
Your response must be concise. 9.07e+08. What is the difference between the Cost (current US$) in Minerals in 2011 and the Cost (current US$) in Forest in 2012?
Your response must be concise. 9.90e+08. What is the difference between the Cost (current US$) of Energy in 2011 and the Cost (current US$) of Forest in 2012?
Make the answer very short. 3.90e+07. What is the difference between the Cost (current US$) in CO2 damage in 2011 and the Cost (current US$) in Minerals in 2013?
Offer a very short reply. -9.35e+08. What is the difference between the Cost (current US$) of CO2 damage in 2011 and the Cost (current US$) of Energy in 2013?
Your answer should be compact. -1.56e+08. What is the difference between the Cost (current US$) in CO2 damage in 2011 and the Cost (current US$) in Forest in 2013?
Offer a terse response. -8.04e+07. What is the difference between the Cost (current US$) in Minerals in 2011 and the Cost (current US$) in Energy in 2013?
Give a very brief answer. 9.10e+08. What is the difference between the Cost (current US$) in Minerals in 2011 and the Cost (current US$) in Forest in 2013?
Keep it short and to the point. 9.85e+08. What is the difference between the Cost (current US$) of Energy in 2011 and the Cost (current US$) of Forest in 2013?
Your answer should be very brief. 3.43e+07. What is the difference between the Cost (current US$) of CO2 damage in 2012 and the Cost (current US$) of Minerals in 2013?
Offer a very short reply. -9.33e+08. What is the difference between the Cost (current US$) of CO2 damage in 2012 and the Cost (current US$) of Energy in 2013?
Give a very brief answer. -1.54e+08. What is the difference between the Cost (current US$) of CO2 damage in 2012 and the Cost (current US$) of Forest in 2013?
Give a very brief answer. -7.84e+07. What is the difference between the Cost (current US$) of Minerals in 2012 and the Cost (current US$) of Energy in 2013?
Provide a short and direct response. 7.77e+08. What is the difference between the Cost (current US$) of Minerals in 2012 and the Cost (current US$) of Forest in 2013?
Your answer should be compact. 8.53e+08. What is the difference between the Cost (current US$) of Energy in 2012 and the Cost (current US$) of Forest in 2013?
Your answer should be very brief. 7.79e+07. What is the average Cost (current US$) of CO2 damage per year?
Your response must be concise. 2.00e+07. What is the average Cost (current US$) in Minerals per year?
Keep it short and to the point. 7.68e+08. What is the average Cost (current US$) in Energy per year?
Your answer should be compact. 2.29e+08. What is the average Cost (current US$) in Forest per year?
Ensure brevity in your answer.  7.08e+07. In the year 2006, what is the difference between the Cost (current US$) in CO2 damage and Cost (current US$) in Minerals?
Make the answer very short. -2.44e+08. In the year 2006, what is the difference between the Cost (current US$) in CO2 damage and Cost (current US$) in Energy?
Ensure brevity in your answer.  -5.48e+08. In the year 2006, what is the difference between the Cost (current US$) in CO2 damage and Cost (current US$) in Forest?
Provide a succinct answer. -2.08e+07. In the year 2006, what is the difference between the Cost (current US$) in Minerals and Cost (current US$) in Energy?
Your answer should be very brief. -3.05e+08. In the year 2006, what is the difference between the Cost (current US$) in Minerals and Cost (current US$) in Forest?
Offer a terse response. 2.23e+08. In the year 2006, what is the difference between the Cost (current US$) of Energy and Cost (current US$) of Forest?
Your response must be concise. 5.28e+08. In the year 2007, what is the difference between the Cost (current US$) in CO2 damage and Cost (current US$) in Minerals?
Offer a very short reply. -6.33e+08. In the year 2007, what is the difference between the Cost (current US$) of CO2 damage and Cost (current US$) of Energy?
Provide a succinct answer. -2.33e+08. In the year 2007, what is the difference between the Cost (current US$) of CO2 damage and Cost (current US$) of Forest?
Make the answer very short. -3.85e+07. In the year 2007, what is the difference between the Cost (current US$) of Minerals and Cost (current US$) of Energy?
Offer a terse response. 4.01e+08. In the year 2007, what is the difference between the Cost (current US$) of Minerals and Cost (current US$) of Forest?
Your response must be concise. 5.95e+08. In the year 2007, what is the difference between the Cost (current US$) of Energy and Cost (current US$) of Forest?
Your response must be concise. 1.94e+08. In the year 2008, what is the difference between the Cost (current US$) in CO2 damage and Cost (current US$) in Minerals?
Your answer should be very brief. -8.29e+08. In the year 2008, what is the difference between the Cost (current US$) in CO2 damage and Cost (current US$) in Energy?
Make the answer very short. -2.62e+08. In the year 2008, what is the difference between the Cost (current US$) of CO2 damage and Cost (current US$) of Forest?
Offer a terse response. -4.69e+07. In the year 2008, what is the difference between the Cost (current US$) of Minerals and Cost (current US$) of Energy?
Make the answer very short. 5.67e+08. In the year 2008, what is the difference between the Cost (current US$) in Minerals and Cost (current US$) in Forest?
Your answer should be compact. 7.82e+08. In the year 2008, what is the difference between the Cost (current US$) in Energy and Cost (current US$) in Forest?
Ensure brevity in your answer.  2.15e+08. In the year 2009, what is the difference between the Cost (current US$) in CO2 damage and Cost (current US$) in Minerals?
Offer a terse response. -4.44e+08. In the year 2009, what is the difference between the Cost (current US$) in CO2 damage and Cost (current US$) in Energy?
Give a very brief answer. -1.16e+08. In the year 2009, what is the difference between the Cost (current US$) in CO2 damage and Cost (current US$) in Forest?
Offer a very short reply. -5.15e+07. In the year 2009, what is the difference between the Cost (current US$) of Minerals and Cost (current US$) of Energy?
Offer a very short reply. 3.28e+08. In the year 2009, what is the difference between the Cost (current US$) in Minerals and Cost (current US$) in Forest?
Your response must be concise. 3.93e+08. In the year 2009, what is the difference between the Cost (current US$) in Energy and Cost (current US$) in Forest?
Give a very brief answer. 6.42e+07. In the year 2010, what is the difference between the Cost (current US$) of CO2 damage and Cost (current US$) of Minerals?
Offer a very short reply. -9.04e+08. In the year 2010, what is the difference between the Cost (current US$) of CO2 damage and Cost (current US$) of Energy?
Give a very brief answer. -9.25e+07. In the year 2010, what is the difference between the Cost (current US$) in CO2 damage and Cost (current US$) in Forest?
Provide a succinct answer. -4.50e+07. In the year 2010, what is the difference between the Cost (current US$) of Minerals and Cost (current US$) of Energy?
Offer a terse response. 8.12e+08. In the year 2010, what is the difference between the Cost (current US$) in Minerals and Cost (current US$) in Forest?
Make the answer very short. 8.59e+08. In the year 2010, what is the difference between the Cost (current US$) in Energy and Cost (current US$) in Forest?
Give a very brief answer. 4.76e+07. In the year 2011, what is the difference between the Cost (current US$) in CO2 damage and Cost (current US$) in Minerals?
Offer a very short reply. -1.07e+09. In the year 2011, what is the difference between the Cost (current US$) in CO2 damage and Cost (current US$) in Energy?
Make the answer very short. -1.15e+08. In the year 2011, what is the difference between the Cost (current US$) in CO2 damage and Cost (current US$) in Forest?
Your answer should be compact. -5.37e+07. In the year 2011, what is the difference between the Cost (current US$) in Minerals and Cost (current US$) in Energy?
Offer a very short reply. 9.51e+08. In the year 2011, what is the difference between the Cost (current US$) of Minerals and Cost (current US$) of Forest?
Offer a very short reply. 1.01e+09. In the year 2011, what is the difference between the Cost (current US$) in Energy and Cost (current US$) in Forest?
Give a very brief answer. 6.10e+07. In the year 2012, what is the difference between the Cost (current US$) of CO2 damage and Cost (current US$) of Minerals?
Provide a short and direct response. -9.31e+08. In the year 2012, what is the difference between the Cost (current US$) of CO2 damage and Cost (current US$) of Energy?
Provide a succinct answer. -1.56e+08. In the year 2012, what is the difference between the Cost (current US$) in CO2 damage and Cost (current US$) in Forest?
Offer a terse response. -7.37e+07. In the year 2012, what is the difference between the Cost (current US$) of Minerals and Cost (current US$) of Energy?
Provide a succinct answer. 7.75e+08. In the year 2012, what is the difference between the Cost (current US$) in Minerals and Cost (current US$) in Forest?
Keep it short and to the point. 8.57e+08. In the year 2012, what is the difference between the Cost (current US$) of Energy and Cost (current US$) of Forest?
Your answer should be very brief. 8.26e+07. In the year 2013, what is the difference between the Cost (current US$) in CO2 damage and Cost (current US$) in Minerals?
Keep it short and to the point. -9.31e+08. In the year 2013, what is the difference between the Cost (current US$) of CO2 damage and Cost (current US$) of Energy?
Provide a succinct answer. -1.52e+08. In the year 2013, what is the difference between the Cost (current US$) of CO2 damage and Cost (current US$) of Forest?
Your answer should be very brief. -7.63e+07. In the year 2013, what is the difference between the Cost (current US$) in Minerals and Cost (current US$) in Energy?
Offer a terse response. 7.79e+08. In the year 2013, what is the difference between the Cost (current US$) in Minerals and Cost (current US$) in Forest?
Provide a short and direct response. 8.55e+08. In the year 2013, what is the difference between the Cost (current US$) in Energy and Cost (current US$) in Forest?
Make the answer very short. 7.56e+07. What is the ratio of the Cost (current US$) of CO2 damage in 2006 to that in 2007?
Provide a short and direct response. 0.84. What is the ratio of the Cost (current US$) in Minerals in 2006 to that in 2007?
Provide a short and direct response. 0.4. What is the ratio of the Cost (current US$) in Energy in 2006 to that in 2007?
Offer a very short reply. 2.26. What is the ratio of the Cost (current US$) in Forest in 2006 to that in 2007?
Keep it short and to the point. 0.63. What is the ratio of the Cost (current US$) of CO2 damage in 2006 to that in 2008?
Provide a short and direct response. 0.78. What is the ratio of the Cost (current US$) in Minerals in 2006 to that in 2008?
Offer a terse response. 0.3. What is the ratio of the Cost (current US$) of Energy in 2006 to that in 2008?
Your response must be concise. 2.01. What is the ratio of the Cost (current US$) in Forest in 2006 to that in 2008?
Ensure brevity in your answer.  0.53. What is the ratio of the Cost (current US$) of CO2 damage in 2006 to that in 2009?
Keep it short and to the point. 0.69. What is the ratio of the Cost (current US$) in Minerals in 2006 to that in 2009?
Make the answer very short. 0.55. What is the ratio of the Cost (current US$) of Energy in 2006 to that in 2009?
Offer a terse response. 4.16. What is the ratio of the Cost (current US$) of Forest in 2006 to that in 2009?
Ensure brevity in your answer.  0.48. What is the ratio of the Cost (current US$) of CO2 damage in 2006 to that in 2010?
Your answer should be very brief. 0.68. What is the ratio of the Cost (current US$) in Minerals in 2006 to that in 2010?
Your answer should be very brief. 0.28. What is the ratio of the Cost (current US$) in Energy in 2006 to that in 2010?
Your answer should be very brief. 4.99. What is the ratio of the Cost (current US$) of Forest in 2006 to that in 2010?
Offer a terse response. 0.53. What is the ratio of the Cost (current US$) of CO2 damage in 2006 to that in 2011?
Give a very brief answer. 0.61. What is the ratio of the Cost (current US$) of Minerals in 2006 to that in 2011?
Make the answer very short. 0.24. What is the ratio of the Cost (current US$) in Energy in 2006 to that in 2011?
Give a very brief answer. 4.1. What is the ratio of the Cost (current US$) in Forest in 2006 to that in 2011?
Give a very brief answer. 0.45. What is the ratio of the Cost (current US$) of CO2 damage in 2006 to that in 2012?
Keep it short and to the point. 0.56. What is the ratio of the Cost (current US$) in Minerals in 2006 to that in 2012?
Keep it short and to the point. 0.27. What is the ratio of the Cost (current US$) in Energy in 2006 to that in 2012?
Offer a very short reply. 3.11. What is the ratio of the Cost (current US$) in Forest in 2006 to that in 2012?
Offer a terse response. 0.35. What is the ratio of the Cost (current US$) of CO2 damage in 2006 to that in 2013?
Ensure brevity in your answer.  0.51. What is the ratio of the Cost (current US$) in Minerals in 2006 to that in 2013?
Your response must be concise. 0.27. What is the ratio of the Cost (current US$) in Energy in 2006 to that in 2013?
Keep it short and to the point. 3.15. What is the ratio of the Cost (current US$) of Forest in 2006 to that in 2013?
Your answer should be compact. 0.33. What is the ratio of the Cost (current US$) of CO2 damage in 2007 to that in 2008?
Keep it short and to the point. 0.92. What is the ratio of the Cost (current US$) in Minerals in 2007 to that in 2008?
Give a very brief answer. 0.77. What is the ratio of the Cost (current US$) in Energy in 2007 to that in 2008?
Offer a very short reply. 0.89. What is the ratio of the Cost (current US$) in Forest in 2007 to that in 2008?
Keep it short and to the point. 0.85. What is the ratio of the Cost (current US$) in CO2 damage in 2007 to that in 2009?
Ensure brevity in your answer.  0.83. What is the ratio of the Cost (current US$) of Minerals in 2007 to that in 2009?
Ensure brevity in your answer.  1.4. What is the ratio of the Cost (current US$) of Energy in 2007 to that in 2009?
Offer a terse response. 1.84. What is the ratio of the Cost (current US$) in Forest in 2007 to that in 2009?
Offer a terse response. 0.77. What is the ratio of the Cost (current US$) in CO2 damage in 2007 to that in 2010?
Ensure brevity in your answer.  0.8. What is the ratio of the Cost (current US$) in Minerals in 2007 to that in 2010?
Offer a terse response. 0.7. What is the ratio of the Cost (current US$) in Energy in 2007 to that in 2010?
Provide a short and direct response. 2.21. What is the ratio of the Cost (current US$) of Forest in 2007 to that in 2010?
Keep it short and to the point. 0.84. What is the ratio of the Cost (current US$) of CO2 damage in 2007 to that in 2011?
Offer a very short reply. 0.72. What is the ratio of the Cost (current US$) of Minerals in 2007 to that in 2011?
Ensure brevity in your answer.  0.6. What is the ratio of the Cost (current US$) of Energy in 2007 to that in 2011?
Provide a short and direct response. 1.82. What is the ratio of the Cost (current US$) in Forest in 2007 to that in 2011?
Your response must be concise. 0.72. What is the ratio of the Cost (current US$) in CO2 damage in 2007 to that in 2012?
Make the answer very short. 0.66. What is the ratio of the Cost (current US$) in Minerals in 2007 to that in 2012?
Your response must be concise. 0.68. What is the ratio of the Cost (current US$) of Energy in 2007 to that in 2012?
Ensure brevity in your answer.  1.38. What is the ratio of the Cost (current US$) of Forest in 2007 to that in 2012?
Offer a very short reply. 0.56. What is the ratio of the Cost (current US$) in CO2 damage in 2007 to that in 2013?
Provide a short and direct response. 0.61. What is the ratio of the Cost (current US$) in Minerals in 2007 to that in 2013?
Your answer should be compact. 0.68. What is the ratio of the Cost (current US$) of Energy in 2007 to that in 2013?
Keep it short and to the point. 1.4. What is the ratio of the Cost (current US$) in Forest in 2007 to that in 2013?
Ensure brevity in your answer.  0.53. What is the ratio of the Cost (current US$) in CO2 damage in 2008 to that in 2009?
Your response must be concise. 0.89. What is the ratio of the Cost (current US$) in Minerals in 2008 to that in 2009?
Make the answer very short. 1.83. What is the ratio of the Cost (current US$) in Energy in 2008 to that in 2009?
Provide a succinct answer. 2.06. What is the ratio of the Cost (current US$) of Forest in 2008 to that in 2009?
Your answer should be very brief. 0.91. What is the ratio of the Cost (current US$) of CO2 damage in 2008 to that in 2010?
Make the answer very short. 0.87. What is the ratio of the Cost (current US$) in Minerals in 2008 to that in 2010?
Offer a terse response. 0.92. What is the ratio of the Cost (current US$) in Energy in 2008 to that in 2010?
Ensure brevity in your answer.  2.48. What is the ratio of the Cost (current US$) in CO2 damage in 2008 to that in 2011?
Your answer should be very brief. 0.78. What is the ratio of the Cost (current US$) in Minerals in 2008 to that in 2011?
Your answer should be compact. 0.78. What is the ratio of the Cost (current US$) of Energy in 2008 to that in 2011?
Make the answer very short. 2.04. What is the ratio of the Cost (current US$) of Forest in 2008 to that in 2011?
Offer a terse response. 0.85. What is the ratio of the Cost (current US$) of CO2 damage in 2008 to that in 2012?
Ensure brevity in your answer.  0.72. What is the ratio of the Cost (current US$) of Minerals in 2008 to that in 2012?
Make the answer very short. 0.89. What is the ratio of the Cost (current US$) in Energy in 2008 to that in 2012?
Your answer should be very brief. 1.54. What is the ratio of the Cost (current US$) of Forest in 2008 to that in 2012?
Provide a succinct answer. 0.66. What is the ratio of the Cost (current US$) of CO2 damage in 2008 to that in 2013?
Offer a very short reply. 0.66. What is the ratio of the Cost (current US$) in Minerals in 2008 to that in 2013?
Provide a succinct answer. 0.88. What is the ratio of the Cost (current US$) of Energy in 2008 to that in 2013?
Make the answer very short. 1.56. What is the ratio of the Cost (current US$) in Forest in 2008 to that in 2013?
Make the answer very short. 0.63. What is the ratio of the Cost (current US$) of CO2 damage in 2009 to that in 2010?
Provide a succinct answer. 0.97. What is the ratio of the Cost (current US$) in Minerals in 2009 to that in 2010?
Make the answer very short. 0.5. What is the ratio of the Cost (current US$) of Energy in 2009 to that in 2010?
Offer a very short reply. 1.2. What is the ratio of the Cost (current US$) in Forest in 2009 to that in 2010?
Offer a very short reply. 1.09. What is the ratio of the Cost (current US$) in CO2 damage in 2009 to that in 2011?
Your answer should be compact. 0.87. What is the ratio of the Cost (current US$) in Minerals in 2009 to that in 2011?
Make the answer very short. 0.43. What is the ratio of the Cost (current US$) of Forest in 2009 to that in 2011?
Offer a very short reply. 0.93. What is the ratio of the Cost (current US$) in CO2 damage in 2009 to that in 2012?
Ensure brevity in your answer.  0.8. What is the ratio of the Cost (current US$) of Minerals in 2009 to that in 2012?
Offer a terse response. 0.49. What is the ratio of the Cost (current US$) in Energy in 2009 to that in 2012?
Offer a very short reply. 0.75. What is the ratio of the Cost (current US$) in Forest in 2009 to that in 2012?
Ensure brevity in your answer.  0.72. What is the ratio of the Cost (current US$) of CO2 damage in 2009 to that in 2013?
Offer a very short reply. 0.74. What is the ratio of the Cost (current US$) in Minerals in 2009 to that in 2013?
Offer a very short reply. 0.48. What is the ratio of the Cost (current US$) of Energy in 2009 to that in 2013?
Provide a succinct answer. 0.76. What is the ratio of the Cost (current US$) in Forest in 2009 to that in 2013?
Keep it short and to the point. 0.69. What is the ratio of the Cost (current US$) in CO2 damage in 2010 to that in 2011?
Offer a terse response. 0.9. What is the ratio of the Cost (current US$) of Minerals in 2010 to that in 2011?
Make the answer very short. 0.85. What is the ratio of the Cost (current US$) in Energy in 2010 to that in 2011?
Provide a short and direct response. 0.82. What is the ratio of the Cost (current US$) in Forest in 2010 to that in 2011?
Your answer should be very brief. 0.86. What is the ratio of the Cost (current US$) in CO2 damage in 2010 to that in 2012?
Provide a succinct answer. 0.82. What is the ratio of the Cost (current US$) of Minerals in 2010 to that in 2012?
Provide a short and direct response. 0.97. What is the ratio of the Cost (current US$) of Energy in 2010 to that in 2012?
Offer a terse response. 0.62. What is the ratio of the Cost (current US$) of Forest in 2010 to that in 2012?
Provide a succinct answer. 0.66. What is the ratio of the Cost (current US$) in CO2 damage in 2010 to that in 2013?
Provide a succinct answer. 0.76. What is the ratio of the Cost (current US$) of Minerals in 2010 to that in 2013?
Provide a short and direct response. 0.97. What is the ratio of the Cost (current US$) of Energy in 2010 to that in 2013?
Your answer should be compact. 0.63. What is the ratio of the Cost (current US$) in Forest in 2010 to that in 2013?
Ensure brevity in your answer.  0.63. What is the ratio of the Cost (current US$) of CO2 damage in 2011 to that in 2012?
Keep it short and to the point. 0.92. What is the ratio of the Cost (current US$) in Minerals in 2011 to that in 2012?
Give a very brief answer. 1.14. What is the ratio of the Cost (current US$) of Energy in 2011 to that in 2012?
Your response must be concise. 0.76. What is the ratio of the Cost (current US$) of Forest in 2011 to that in 2012?
Provide a short and direct response. 0.78. What is the ratio of the Cost (current US$) of CO2 damage in 2011 to that in 2013?
Give a very brief answer. 0.85. What is the ratio of the Cost (current US$) in Minerals in 2011 to that in 2013?
Keep it short and to the point. 1.14. What is the ratio of the Cost (current US$) in Energy in 2011 to that in 2013?
Make the answer very short. 0.77. What is the ratio of the Cost (current US$) of Forest in 2011 to that in 2013?
Offer a terse response. 0.74. What is the ratio of the Cost (current US$) of CO2 damage in 2012 to that in 2013?
Offer a terse response. 0.92. What is the ratio of the Cost (current US$) in Energy in 2012 to that in 2013?
Offer a very short reply. 1.01. What is the ratio of the Cost (current US$) in Forest in 2012 to that in 2013?
Your response must be concise. 0.95. What is the difference between the highest and the second highest Cost (current US$) of CO2 damage?
Your answer should be very brief. 2.04e+06. What is the difference between the highest and the second highest Cost (current US$) of Minerals?
Provide a short and direct response. 1.31e+08. What is the difference between the highest and the second highest Cost (current US$) in Energy?
Make the answer very short. 2.83e+08. What is the difference between the highest and the second highest Cost (current US$) of Forest?
Keep it short and to the point. 4.69e+06. What is the difference between the highest and the lowest Cost (current US$) of CO2 damage?
Make the answer very short. 1.29e+07. What is the difference between the highest and the lowest Cost (current US$) of Minerals?
Provide a short and direct response. 8.31e+08. What is the difference between the highest and the lowest Cost (current US$) of Energy?
Your answer should be compact. 4.49e+08. What is the difference between the highest and the lowest Cost (current US$) of Forest?
Make the answer very short. 6.84e+07. 